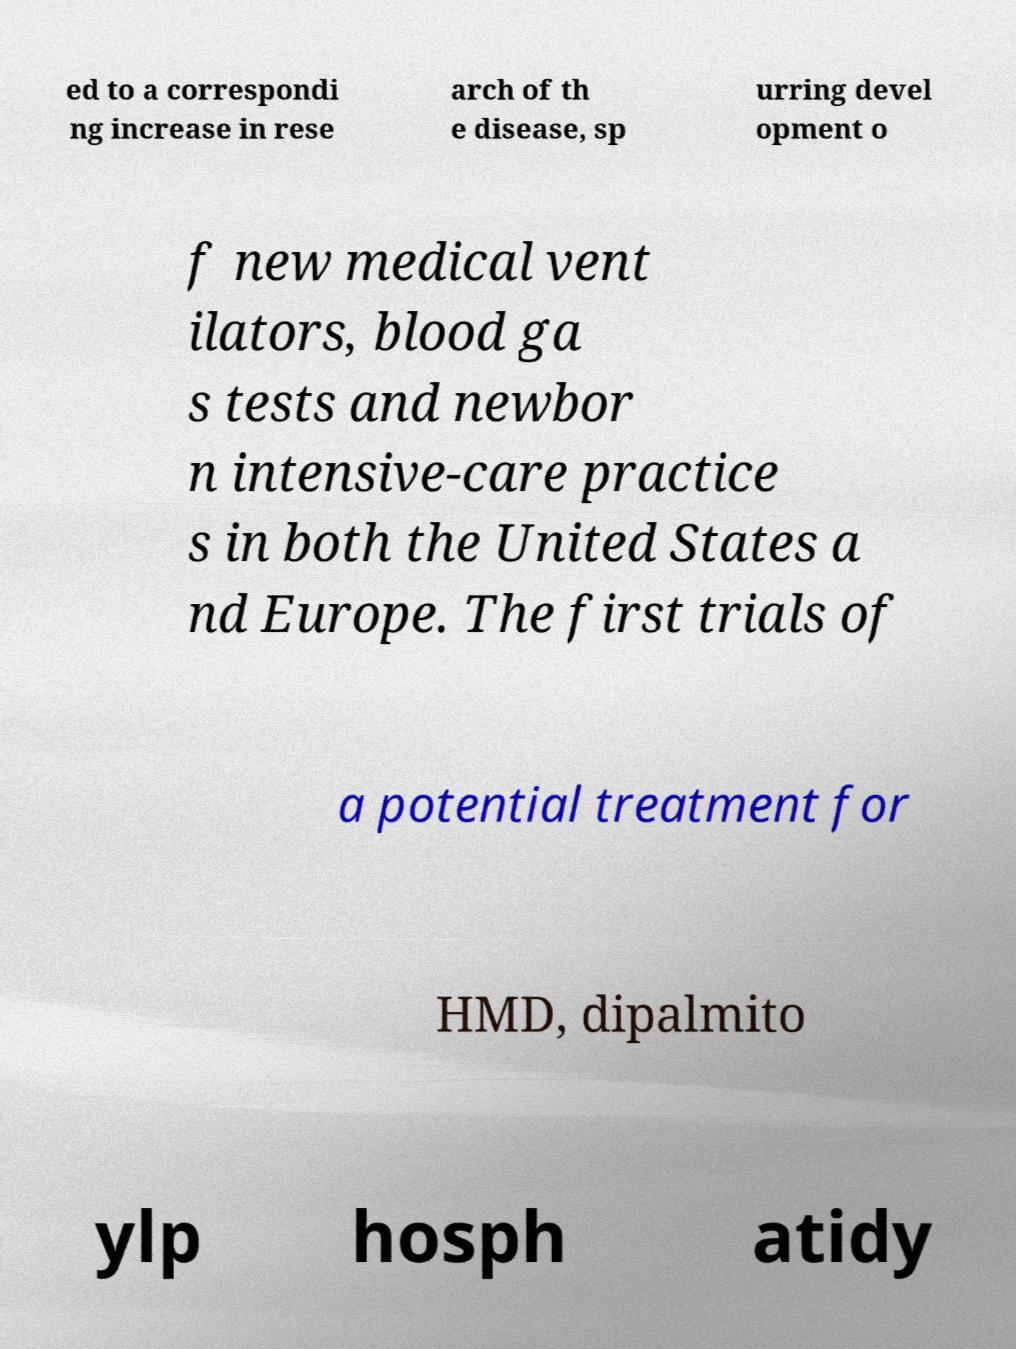What messages or text are displayed in this image? I need them in a readable, typed format. ed to a correspondi ng increase in rese arch of th e disease, sp urring devel opment o f new medical vent ilators, blood ga s tests and newbor n intensive-care practice s in both the United States a nd Europe. The first trials of a potential treatment for HMD, dipalmito ylp hosph atidy 